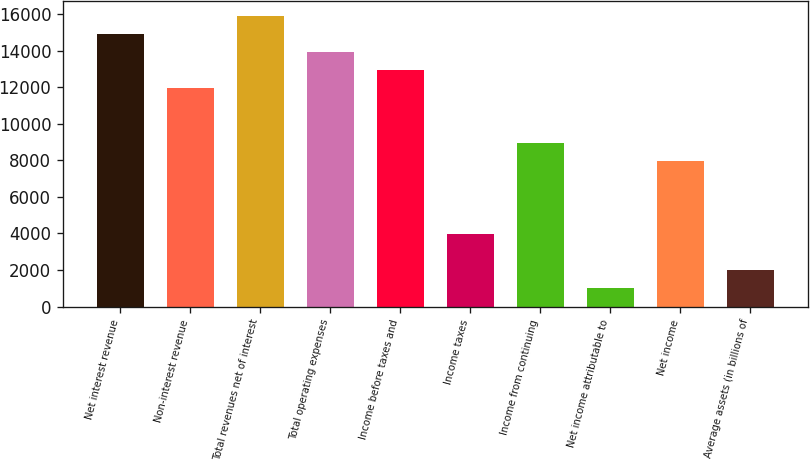Convert chart to OTSL. <chart><loc_0><loc_0><loc_500><loc_500><bar_chart><fcel>Net interest revenue<fcel>Non-interest revenue<fcel>Total revenues net of interest<fcel>Total operating expenses<fcel>Income before taxes and<fcel>Income taxes<fcel>Income from continuing<fcel>Net income attributable to<fcel>Net income<fcel>Average assets (in billions of<nl><fcel>14913.5<fcel>11933<fcel>15907<fcel>13920<fcel>12926.5<fcel>3985<fcel>8952.5<fcel>1004.5<fcel>7959<fcel>1998<nl></chart> 